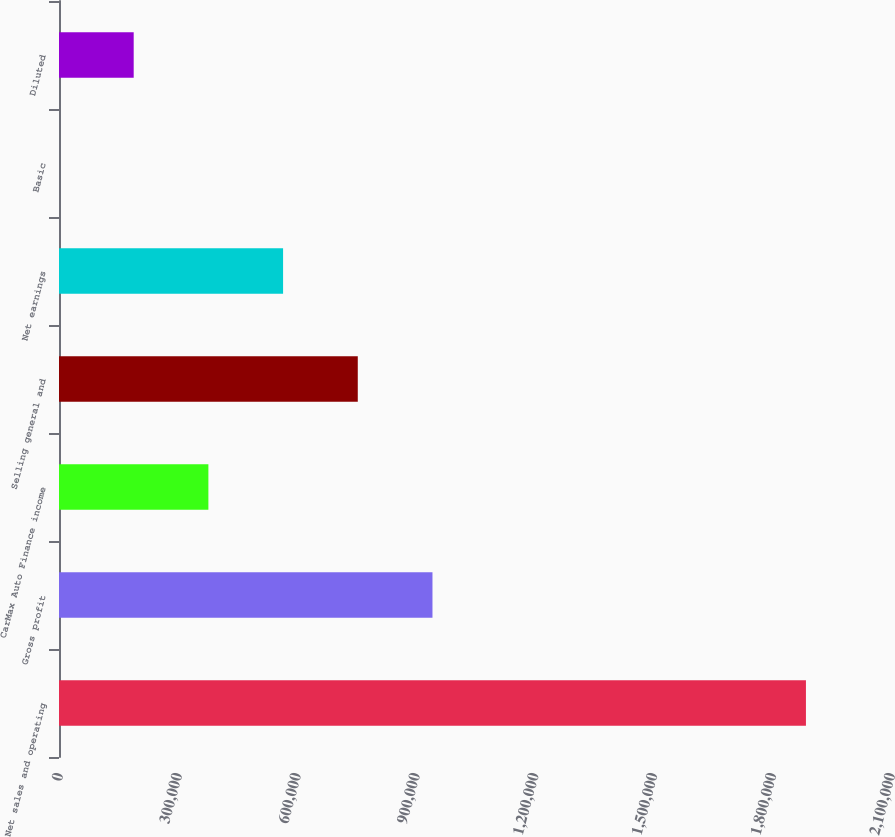Convert chart. <chart><loc_0><loc_0><loc_500><loc_500><bar_chart><fcel>Net sales and operating<fcel>Gross profit<fcel>CarMax Auto Finance income<fcel>Selling general and<fcel>Net earnings<fcel>Basic<fcel>Diluted<nl><fcel>1.8853e+06<fcel>942650<fcel>377060<fcel>754120<fcel>565590<fcel>0.14<fcel>188530<nl></chart> 